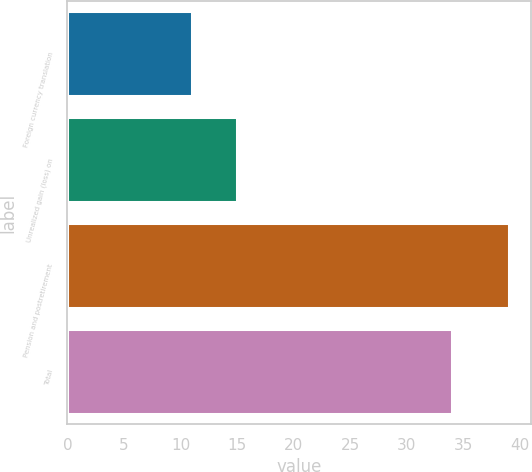<chart> <loc_0><loc_0><loc_500><loc_500><bar_chart><fcel>Foreign currency translation<fcel>Unrealized gain (loss) on<fcel>Pension and postretirement<fcel>Total<nl><fcel>11<fcel>15<fcel>39<fcel>34<nl></chart> 